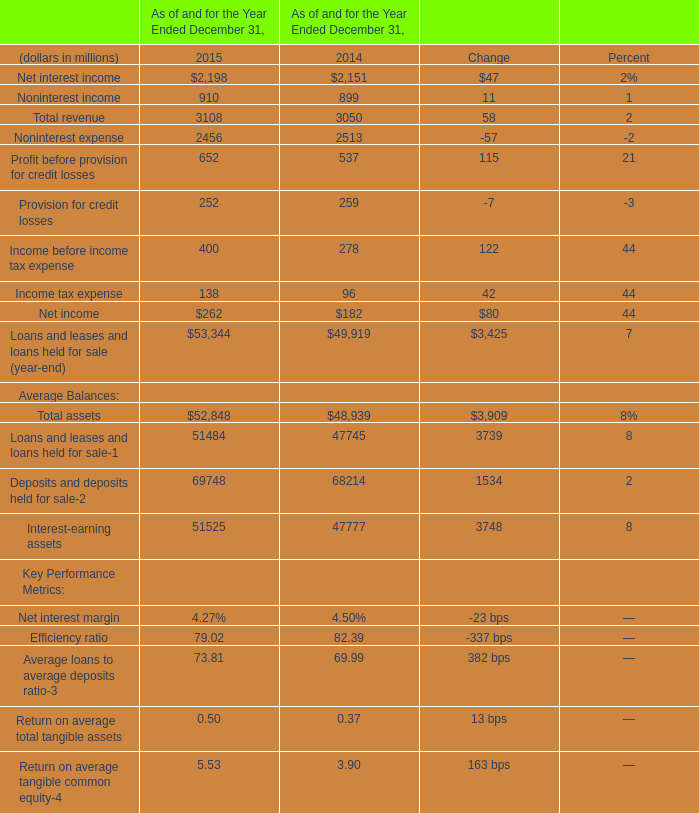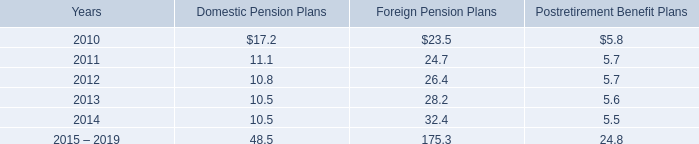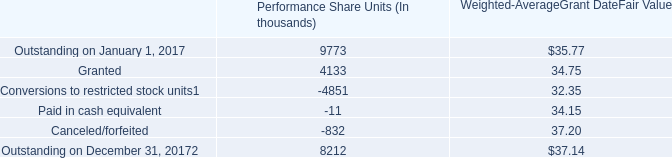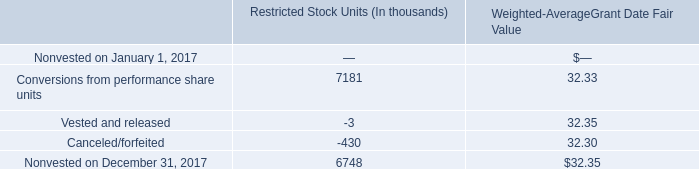What was the average value of Noninterest expense, Profit before provision for credit losses, Provision for credit losses in 2015? (in millions) 
Computations: (((2456 + 652) + 252) / 3)
Answer: 1120.0. 